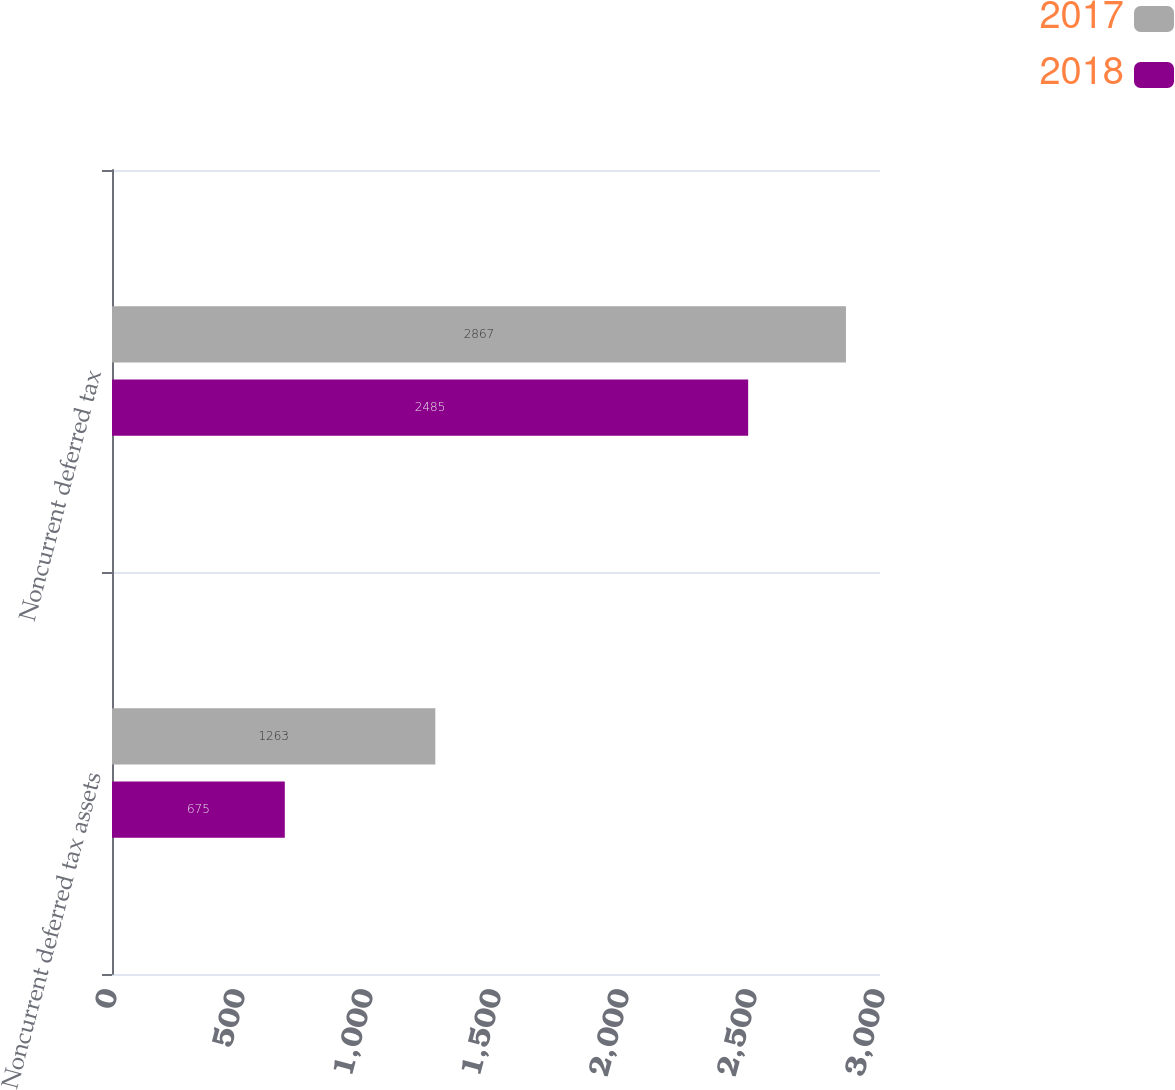Convert chart. <chart><loc_0><loc_0><loc_500><loc_500><stacked_bar_chart><ecel><fcel>Noncurrent deferred tax assets<fcel>Noncurrent deferred tax<nl><fcel>2017<fcel>1263<fcel>2867<nl><fcel>2018<fcel>675<fcel>2485<nl></chart> 